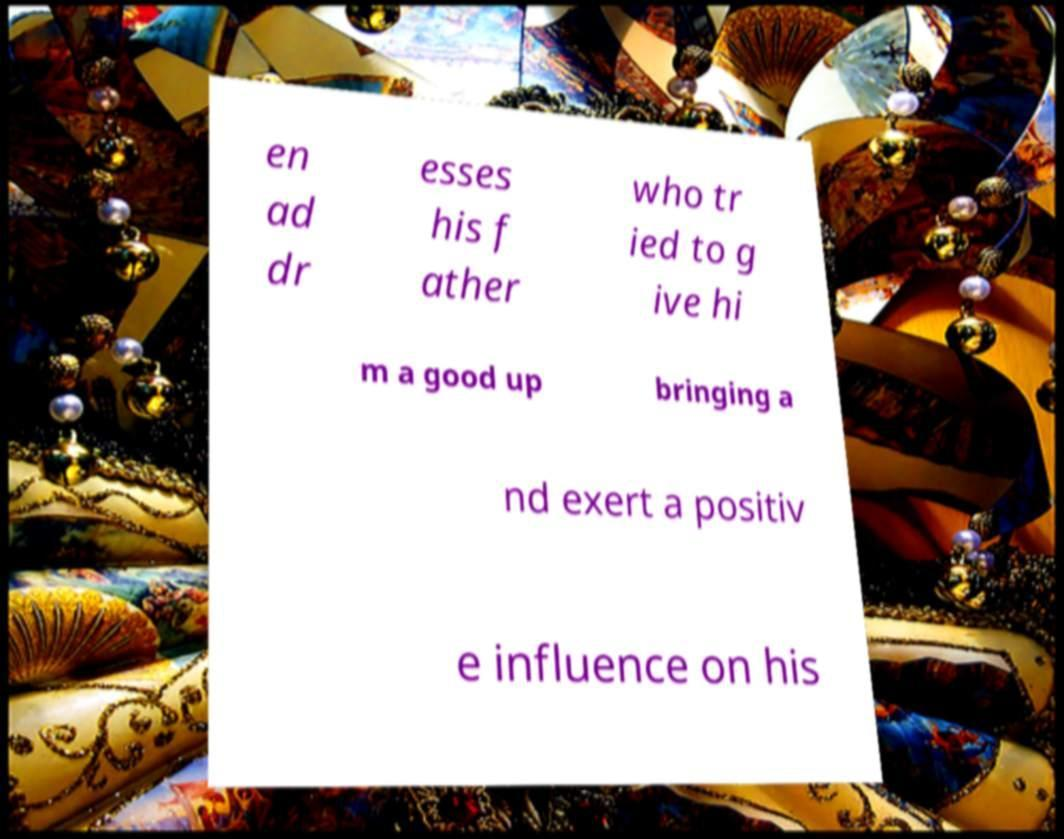Could you extract and type out the text from this image? en ad dr esses his f ather who tr ied to g ive hi m a good up bringing a nd exert a positiv e influence on his 